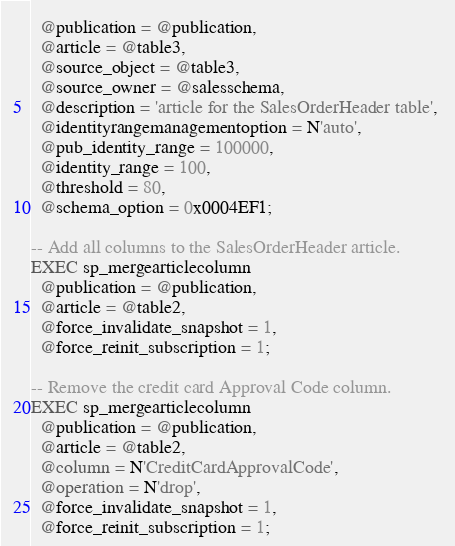Convert code to text. <code><loc_0><loc_0><loc_500><loc_500><_SQL_>  @publication = @publication, 
  @article = @table3, 
  @source_object = @table3, 
  @source_owner = @salesschema,
  @description = 'article for the SalesOrderHeader table', 
  @identityrangemanagementoption = N'auto', 
  @pub_identity_range = 100000, 
  @identity_range = 100, 
  @threshold = 80,
  @schema_option = 0x0004EF1;

-- Add all columns to the SalesOrderHeader article.
EXEC sp_mergearticlecolumn 
  @publication = @publication, 
  @article = @table2, 
  @force_invalidate_snapshot = 1, 
  @force_reinit_subscription = 1;

-- Remove the credit card Approval Code column.
EXEC sp_mergearticlecolumn 
  @publication = @publication, 
  @article = @table2, 
  @column = N'CreditCardApprovalCode', 
  @operation = N'drop', 
  @force_invalidate_snapshot = 1, 
  @force_reinit_subscription = 1;
</code> 